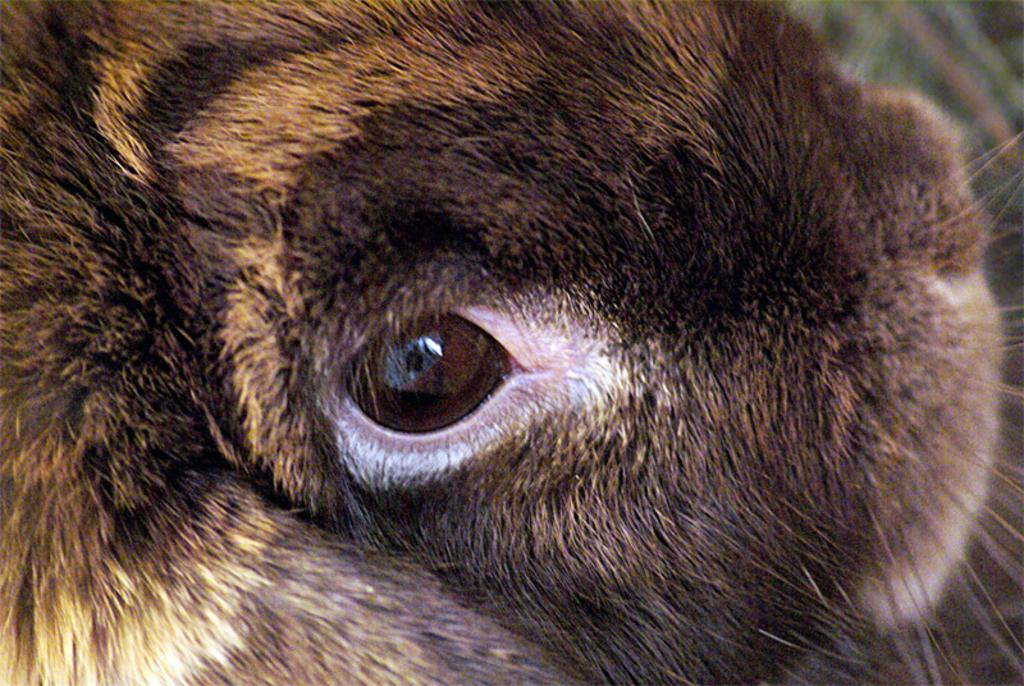What is the main subject of the picture? The main subject of the picture is an animal's eye. What else can be seen in the picture besides the eye? The fur of the animal is visible in the picture. What color is the animal's fur? The fur is brown in color. Is there a basket hanging from the animal's fur in the picture? No, there is no basket present in the image. 